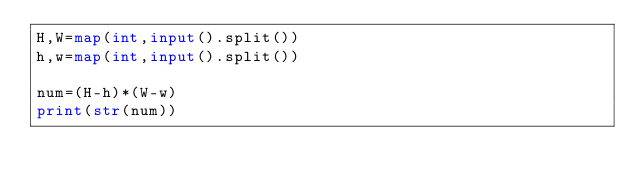<code> <loc_0><loc_0><loc_500><loc_500><_Python_>H,W=map(int,input().split())
h,w=map(int,input().split())

num=(H-h)*(W-w)
print(str(num))</code> 